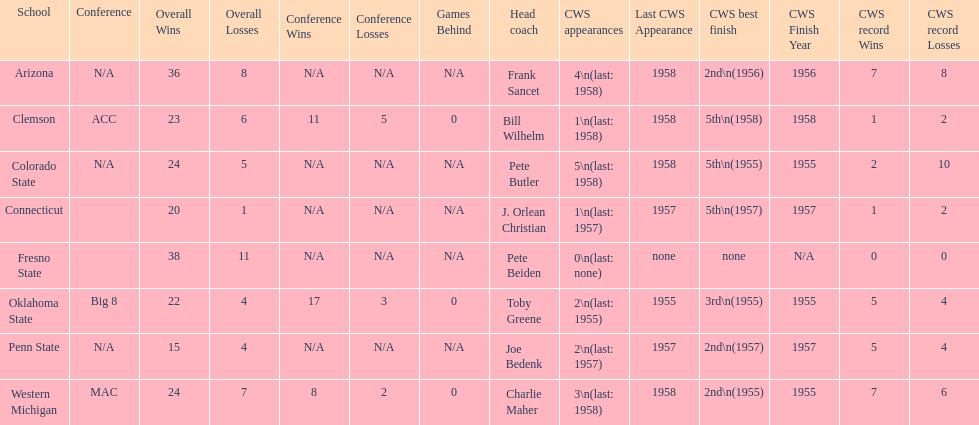Does clemson or western michigan have more cws appearances? Western Michigan. 